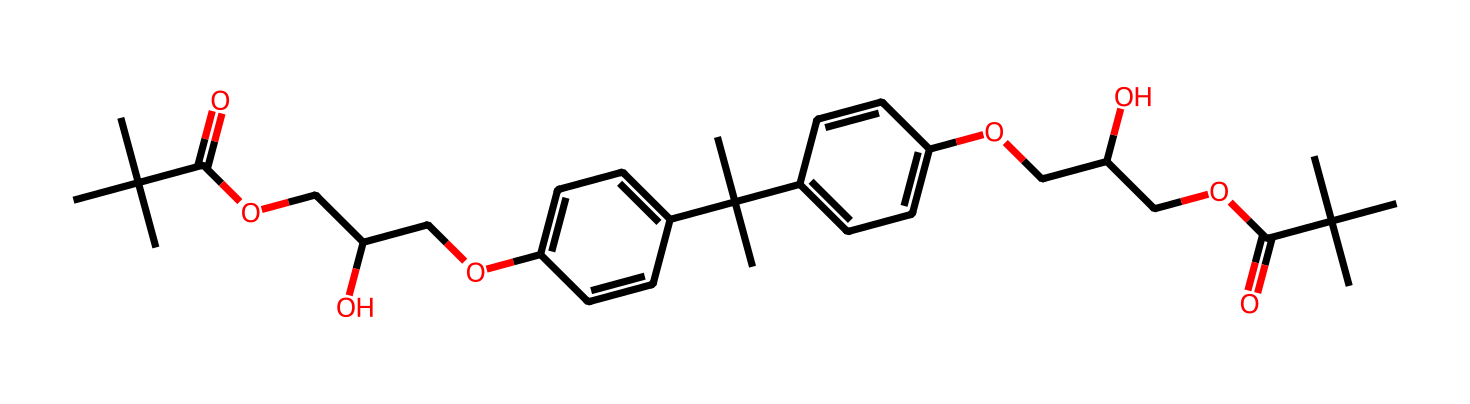What is the main functional group present in the epoxy acrylate structure? The presence of the ester group (–C(=O)O–) in the chemical structure indicates the presence of ester functional groups. Esters are characterized by the carbonyl group (C=O) adjacent to an ether linkage (–O–).
Answer: ester How many aromatic rings are present in this chemical? The structure contains two aromatic rings (phenyl groups) represented in the molecule, which are indicated by the alternating double bonds and the cyclic arrangement of carbon atoms.
Answer: two What type of polymerization process is typical for this epoxy acrylate in photoresists? The typical polymerization process for epoxy acrylates involves radical polymerization, where radicals are generated to initiate the process. This allows the acrylate functionalities to link with one another, forming a crosslinked polymer network.
Answer: radical polymerization How many oxygen atoms are in the molecule? To determine the number of oxygen atoms, we can count the oxygen atoms in the structure. There are six oxygen atoms in total throughout the entire molecule.
Answer: six What type of application is this epoxy acrylate primarily used for? Due to its properties as a photoresist, this epoxy acrylate is primarily used in protective coatings and surface finishes, particularly in applications requiring resistance to solvents and wear in sports equipment.
Answer: protective coatings Which part of the structure contributes to crosslinking during polymerization? The acrylate functional groups (–C=C) are the parts of the structure that facilitate crosslinking when subjected to UV light, leading to a hardened, stable network.
Answer: acrylate functional groups 